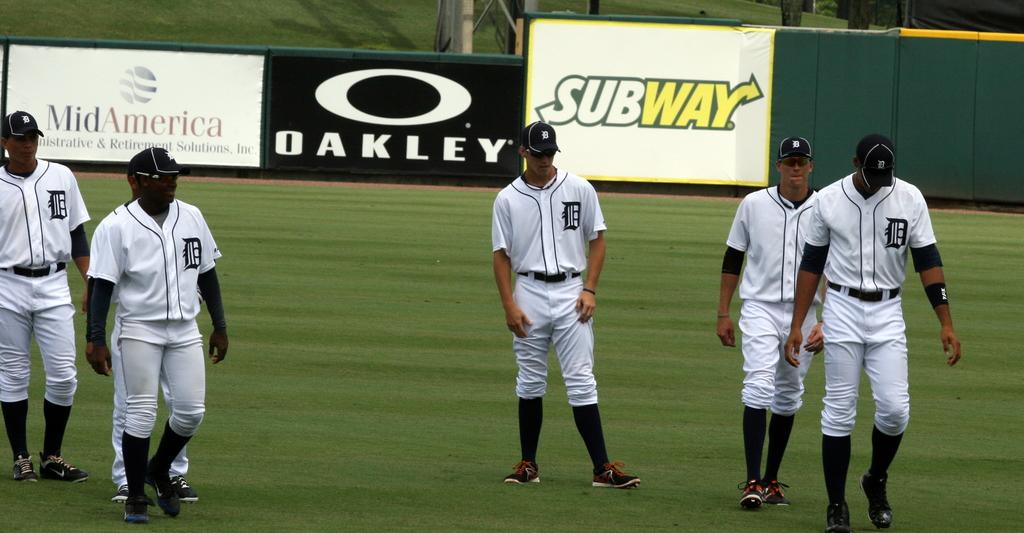What companies sponsor this park?
Provide a succinct answer. Midamerica, oakley, subway. What letter is shown on the jerseys?
Your answer should be very brief. D. 